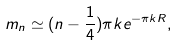<formula> <loc_0><loc_0><loc_500><loc_500>m _ { n } \simeq ( n - \frac { 1 } { 4 } ) \pi k e ^ { - \pi k R } ,</formula> 